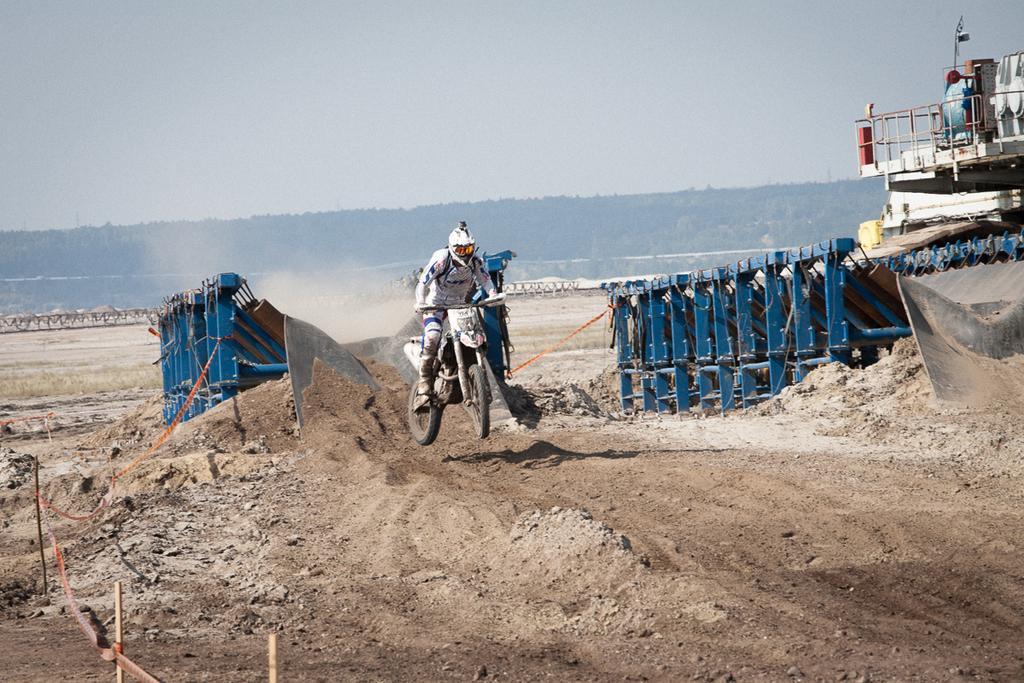Please provide a concise description of this image. In the foreground I can see a person is riding a bike, metal rods and a crane on the ground. In the background I can see trees, fence and the sky. This image is taken may be during a day. 